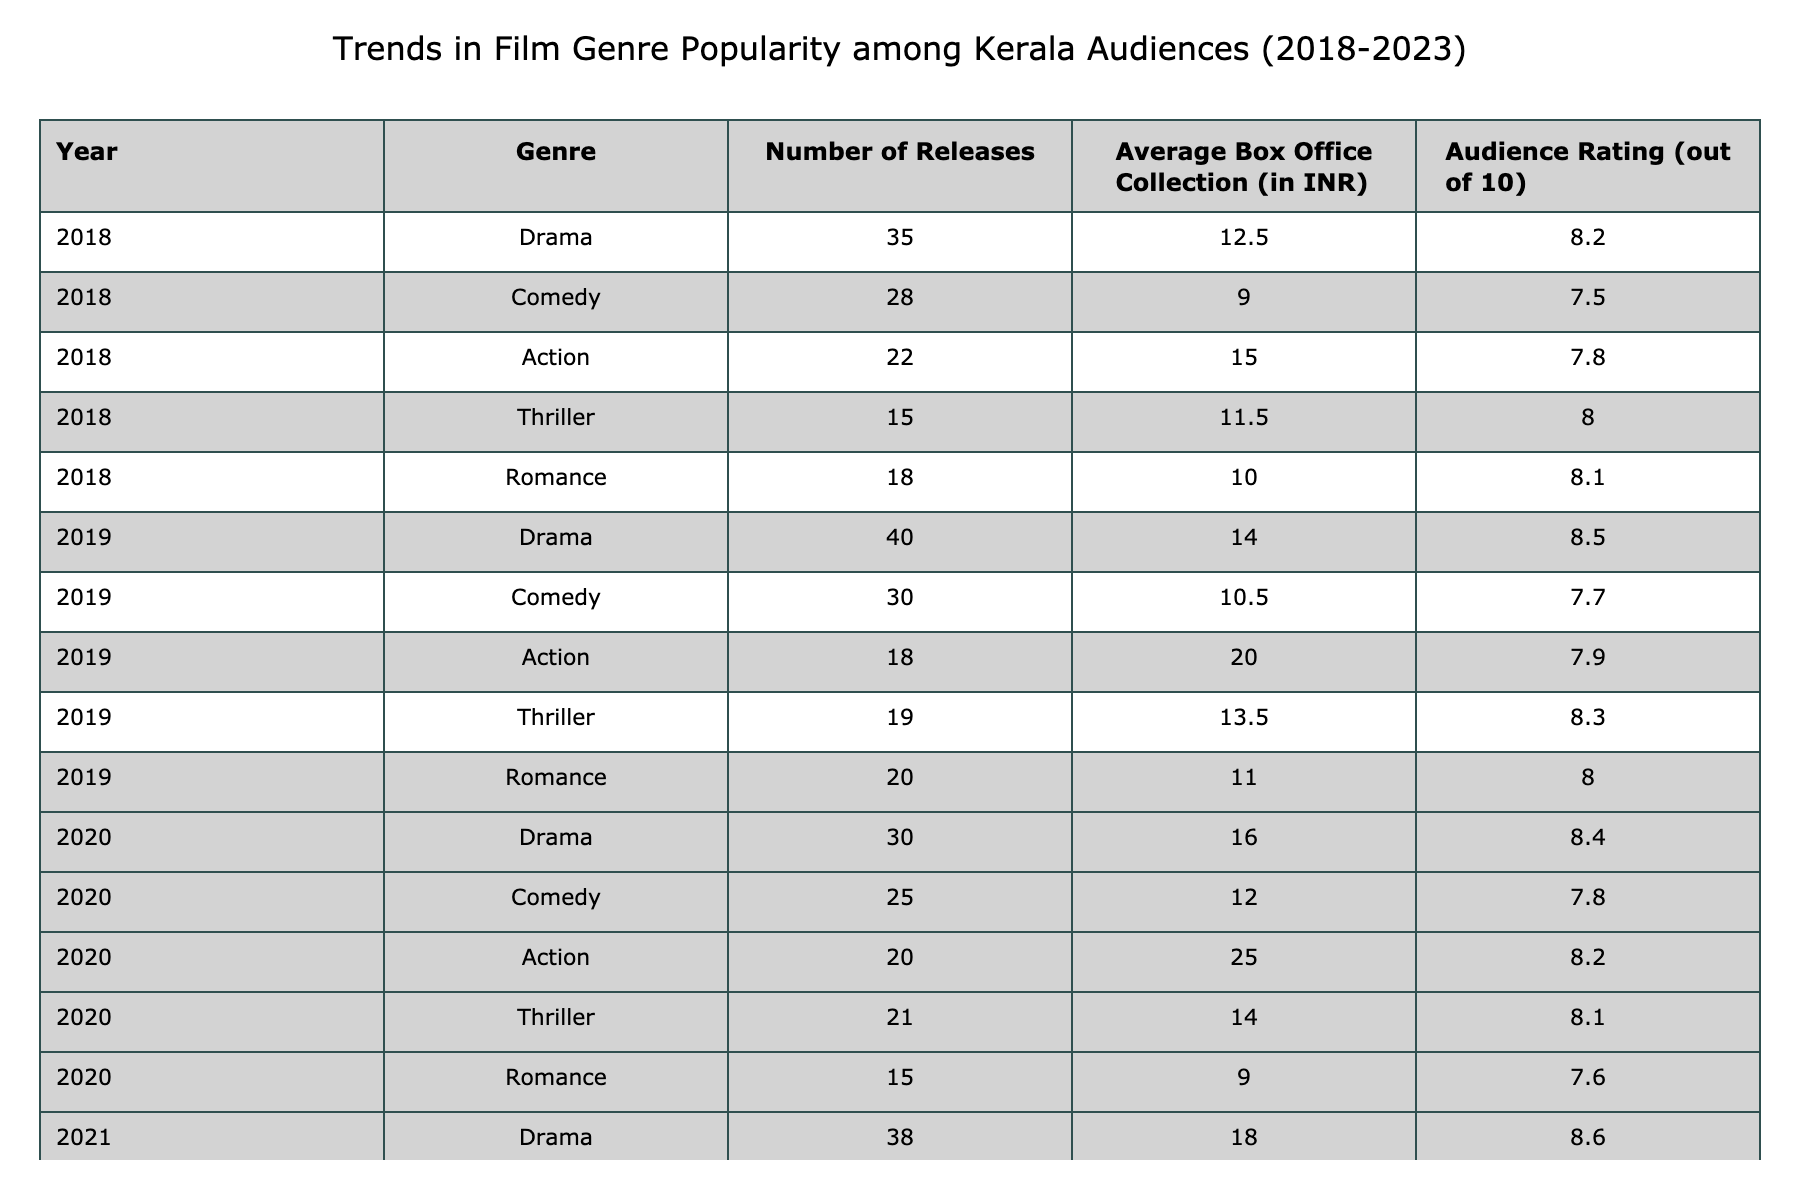What genre had the highest average box office collection in 2023? Looking at the year 2023 in the table, the Action genre had an average box office collection of 35.0 INR, which is higher than the other genres listed for that year.
Answer: Action Which genre saw the largest increase in audience rating from 2018 to 2023? By evaluating the audience ratings, Drama in 2018 had a rating of 8.2 and increased to 8.8 in 2023, resulting in an increase of 0.6. Comparatively, other genres had lesser increases, with the closest being Action, which went from 7.8 in 2018 to 8.7 in 2023, an increase of 0.9. Therefore, Action had the largest increase.
Answer: Action In which year was the total number of Action releases the lowest? The table shows that the lowest number of Action releases occurred in 2019, with just 18 releases, while the numbers for other years are higher.
Answer: 2019 What is the average number of Comedy films released from 2018 to 2023? To calculate the average, we add the number of Comedy films released each year: 28 (2018) + 30 (2019) + 25 (2020) + 26 (2021) + 27 (2022) + 29 (2023) = 165. We then divide by the number of years, which is 6. So, 165/6 = 27.5.
Answer: 27.5 Was the average box office collection for Romance films greater than that of Thriller films in 2022? The Romance genre had an average box office collection of 14.0 INR in 2022, while the Thriller genre had an average collection of 18.0 INR. Since 14.0 is less than 18.0, the statement is false.
Answer: No Which genre had the highest number of releases in 2022 and what was its average box office collection that year? In 2022, Drama had the highest number of releases, totaling 42, and its average box office collection was 20.0 INR.
Answer: Drama, 20.0 INR What pattern can be observed in the audience ratings for Action films from 2018 to 2023? The audience ratings for Action films show a consistent increase each year: 7.8 in 2018, 7.9 in 2019, 8.2 in 2020, 8.4 in 2021, 8.6 in 2022, and 8.7 in 2023. This indicates a steady upward trend in audience ratings for this genre.
Answer: Consistent increase How much did the average box office collection for Drama films increase from 2019 to 2023? Drama films had an average box office collection of 14.0 in 2019 and 22.5 in 2023. The difference is 22.5 - 14.0 = 8.5, indicating the increase.
Answer: 8.5 INR Which year had the highest diversity in genres based on average box office collections? To determine this, we can compare the differences in average box office collections among all genres for each year. In 2022, the collection for Action (30.0) significantly exceeded that of others, indicating higher diversity. Thus, 2021 might also reflect notable genre performance differences. A closer look shows 2022 had notable dispersive collections with 20.0 for Drama and 30.0 for Action, creating novelty.
Answer: 2021 Did the total number of releases in 2023 exceed the total number of releases in any other year? Adding the releases for 2023: 44 (Drama) + 29 (Comedy) + 30 (Action) + 25 (Thriller) + 20 (Romance) = 148. Reviewing previous years, 2022 had the highest total of 141, hence 2023 exceeds all prior years indicating growth.
Answer: Yes 